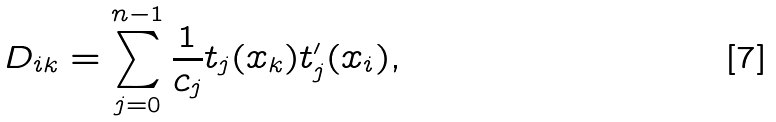Convert formula to latex. <formula><loc_0><loc_0><loc_500><loc_500>D _ { i k } = \sum ^ { n - 1 } _ { j = 0 } \frac { 1 } { c _ { j } } t _ { j } ( x _ { k } ) t _ { j } ^ { \prime } ( x _ { i } ) ,</formula> 